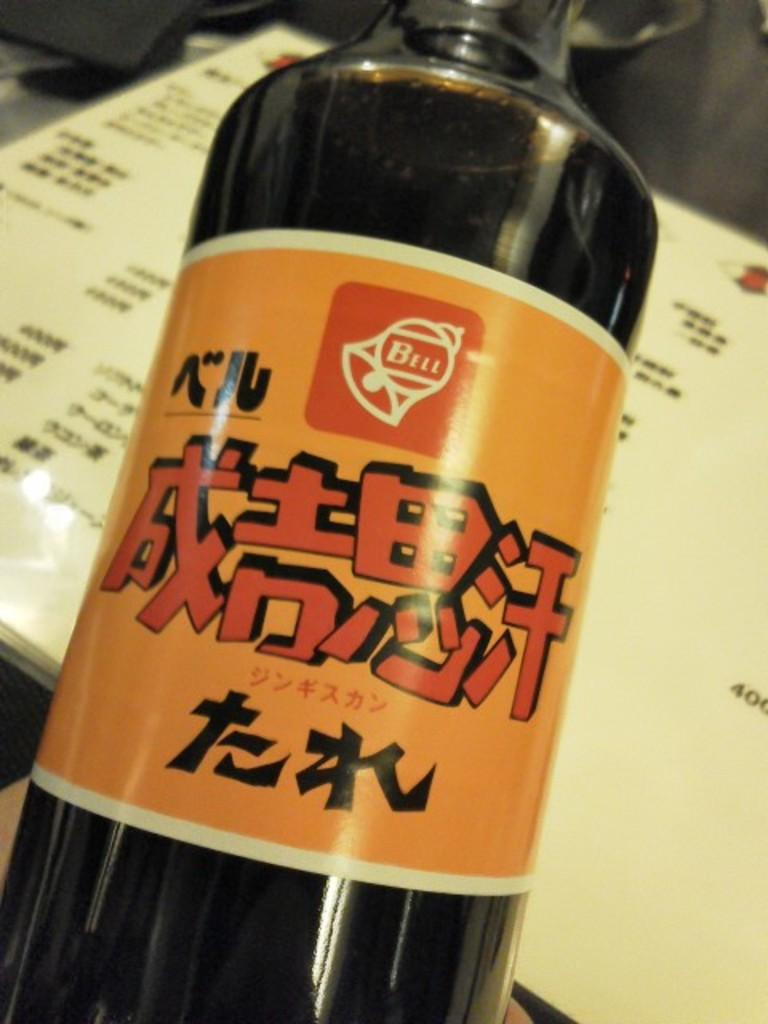<image>
Summarize the visual content of the image. A black bottle of liquid with the bell logo on the top of the label. 